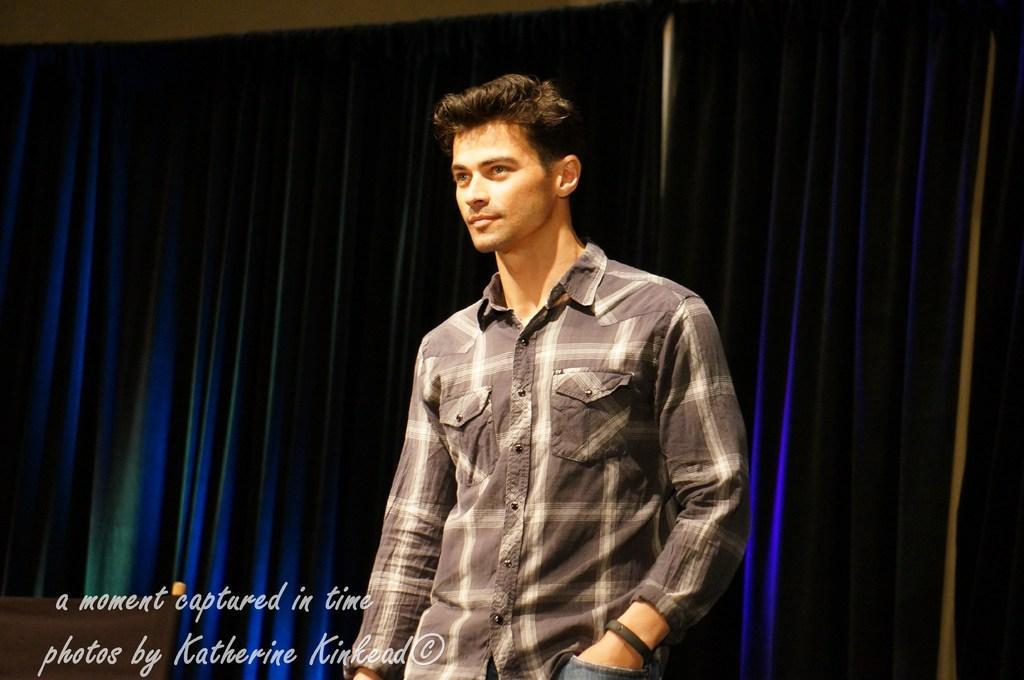In one or two sentences, can you explain what this image depicts? In this image in the center there is one man who is standing and in the background there is a wall and curtains, at the bottom of the image there is some text. 